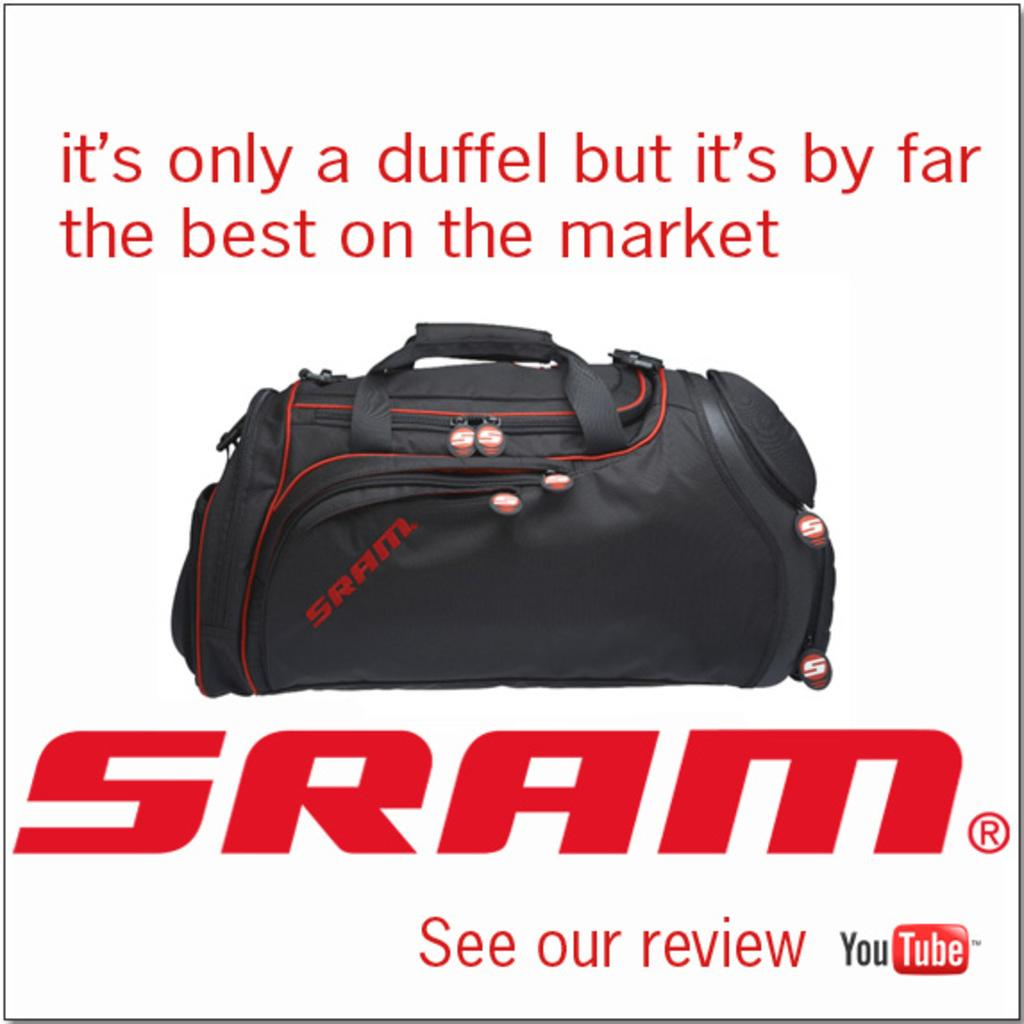What object can be seen in the image? There is a bag in the image. What color is the bag? The bag is black in color. Is there any text or writing visible on the bag? Yes, there is text or writing visible on the image. How many friends are holding the scissors in the image? There are no friends or scissors present in the image. 